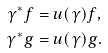Convert formula to latex. <formula><loc_0><loc_0><loc_500><loc_500>\gamma ^ { \ast } f & = u ( \gamma ) f , \\ \gamma ^ { \ast } g & = u ( \gamma ) g .</formula> 